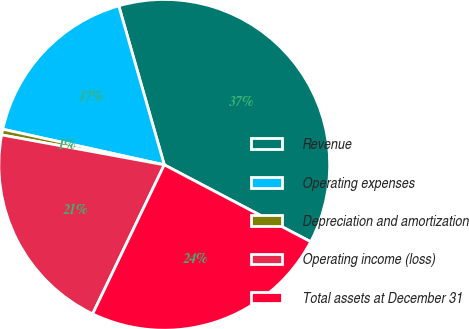<chart> <loc_0><loc_0><loc_500><loc_500><pie_chart><fcel>Revenue<fcel>Operating expenses<fcel>Depreciation and amortization<fcel>Operating income (loss)<fcel>Total assets at December 31<nl><fcel>37.14%<fcel>17.11%<fcel>0.56%<fcel>20.77%<fcel>24.43%<nl></chart> 